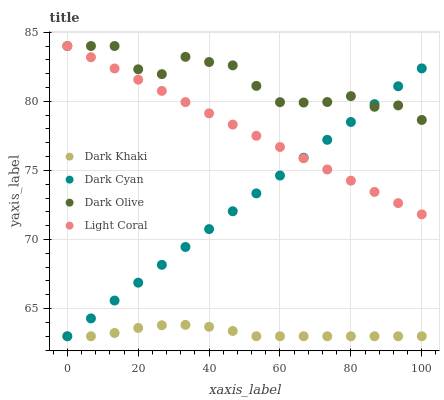Does Dark Khaki have the minimum area under the curve?
Answer yes or no. Yes. Does Dark Olive have the maximum area under the curve?
Answer yes or no. Yes. Does Dark Cyan have the minimum area under the curve?
Answer yes or no. No. Does Dark Cyan have the maximum area under the curve?
Answer yes or no. No. Is Dark Cyan the smoothest?
Answer yes or no. Yes. Is Dark Olive the roughest?
Answer yes or no. Yes. Is Dark Olive the smoothest?
Answer yes or no. No. Is Dark Cyan the roughest?
Answer yes or no. No. Does Dark Khaki have the lowest value?
Answer yes or no. Yes. Does Dark Olive have the lowest value?
Answer yes or no. No. Does Light Coral have the highest value?
Answer yes or no. Yes. Does Dark Cyan have the highest value?
Answer yes or no. No. Is Dark Khaki less than Dark Olive?
Answer yes or no. Yes. Is Light Coral greater than Dark Khaki?
Answer yes or no. Yes. Does Dark Olive intersect Dark Cyan?
Answer yes or no. Yes. Is Dark Olive less than Dark Cyan?
Answer yes or no. No. Is Dark Olive greater than Dark Cyan?
Answer yes or no. No. Does Dark Khaki intersect Dark Olive?
Answer yes or no. No. 